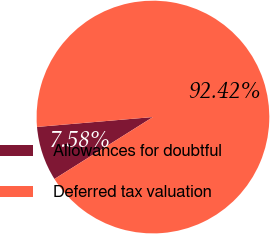<chart> <loc_0><loc_0><loc_500><loc_500><pie_chart><fcel>Allowances for doubtful<fcel>Deferred tax valuation<nl><fcel>7.58%<fcel>92.42%<nl></chart> 